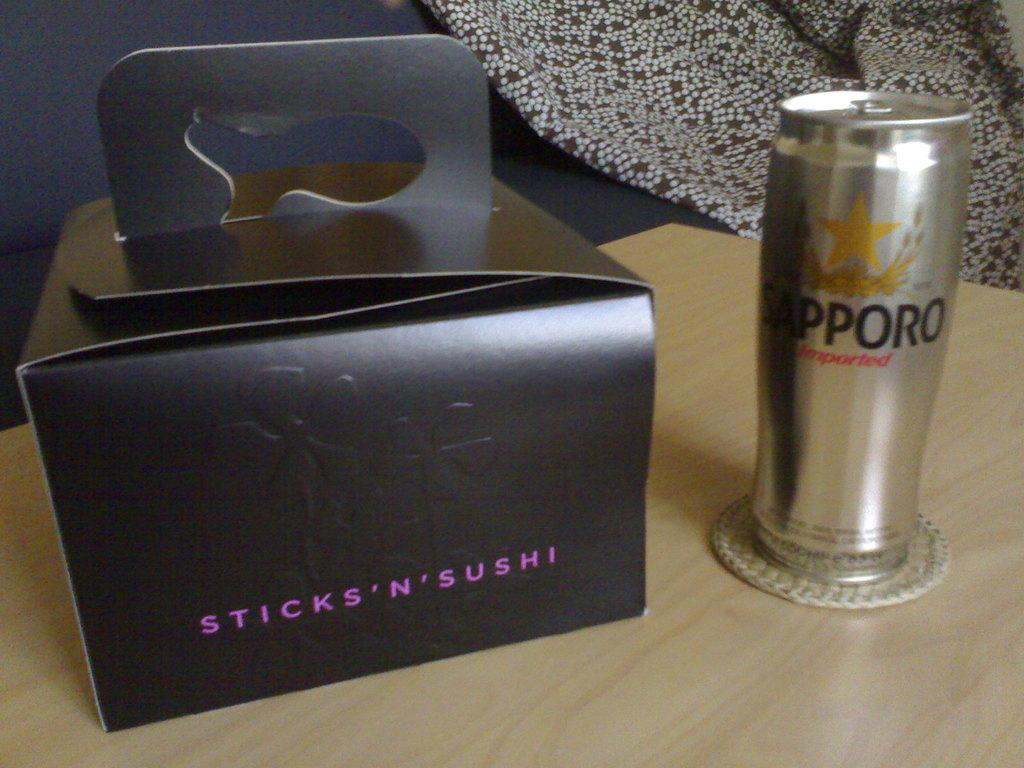<image>
Describe the image concisely. Sapporo drink next to a black box of Sticks N Sushi. 